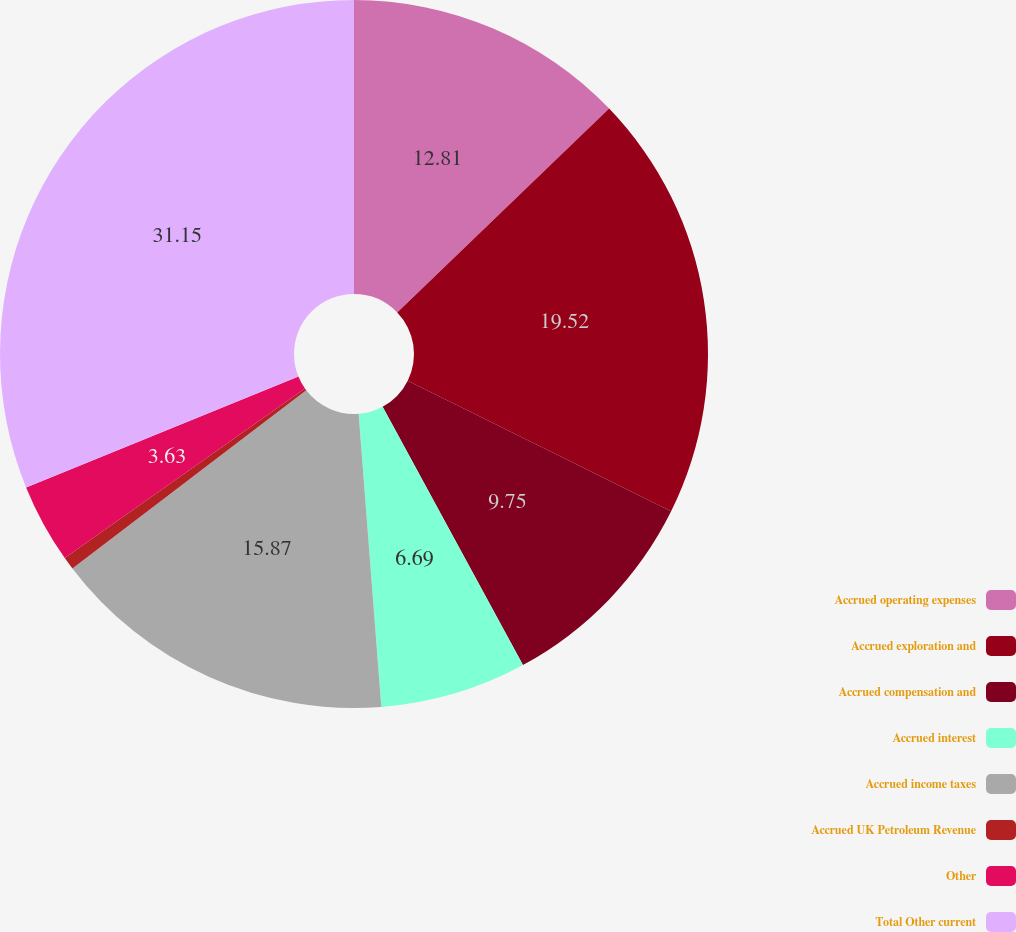Convert chart to OTSL. <chart><loc_0><loc_0><loc_500><loc_500><pie_chart><fcel>Accrued operating expenses<fcel>Accrued exploration and<fcel>Accrued compensation and<fcel>Accrued interest<fcel>Accrued income taxes<fcel>Accrued UK Petroleum Revenue<fcel>Other<fcel>Total Other current<nl><fcel>12.81%<fcel>19.52%<fcel>9.75%<fcel>6.69%<fcel>15.87%<fcel>0.58%<fcel>3.63%<fcel>31.15%<nl></chart> 